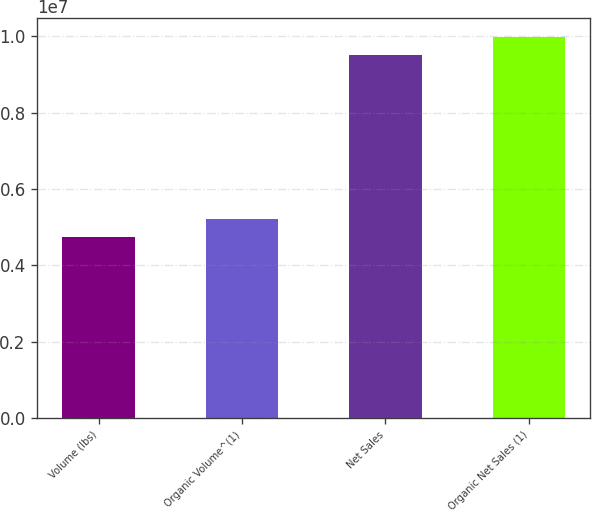<chart> <loc_0><loc_0><loc_500><loc_500><bar_chart><fcel>Volume (lbs)<fcel>Organic Volume^(1)<fcel>Net Sales<fcel>Organic Net Sales (1)<nl><fcel>4.73728e+06<fcel>5.21328e+06<fcel>9.49732e+06<fcel>9.97332e+06<nl></chart> 